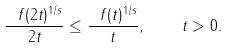<formula> <loc_0><loc_0><loc_500><loc_500>\frac { \ f ( 2 t ) ^ { 1 / s } } { 2 t } \leq \frac { \ f ( t ) ^ { 1 / s } } { t } , \quad t > 0 .</formula> 